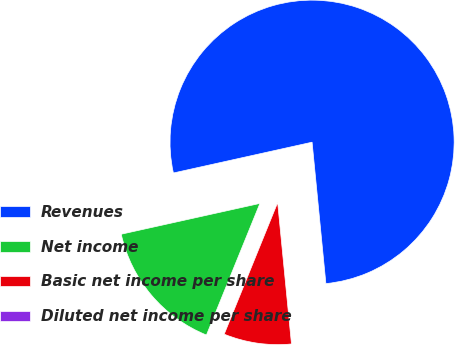Convert chart to OTSL. <chart><loc_0><loc_0><loc_500><loc_500><pie_chart><fcel>Revenues<fcel>Net income<fcel>Basic net income per share<fcel>Diluted net income per share<nl><fcel>76.92%<fcel>15.38%<fcel>7.69%<fcel>0.0%<nl></chart> 